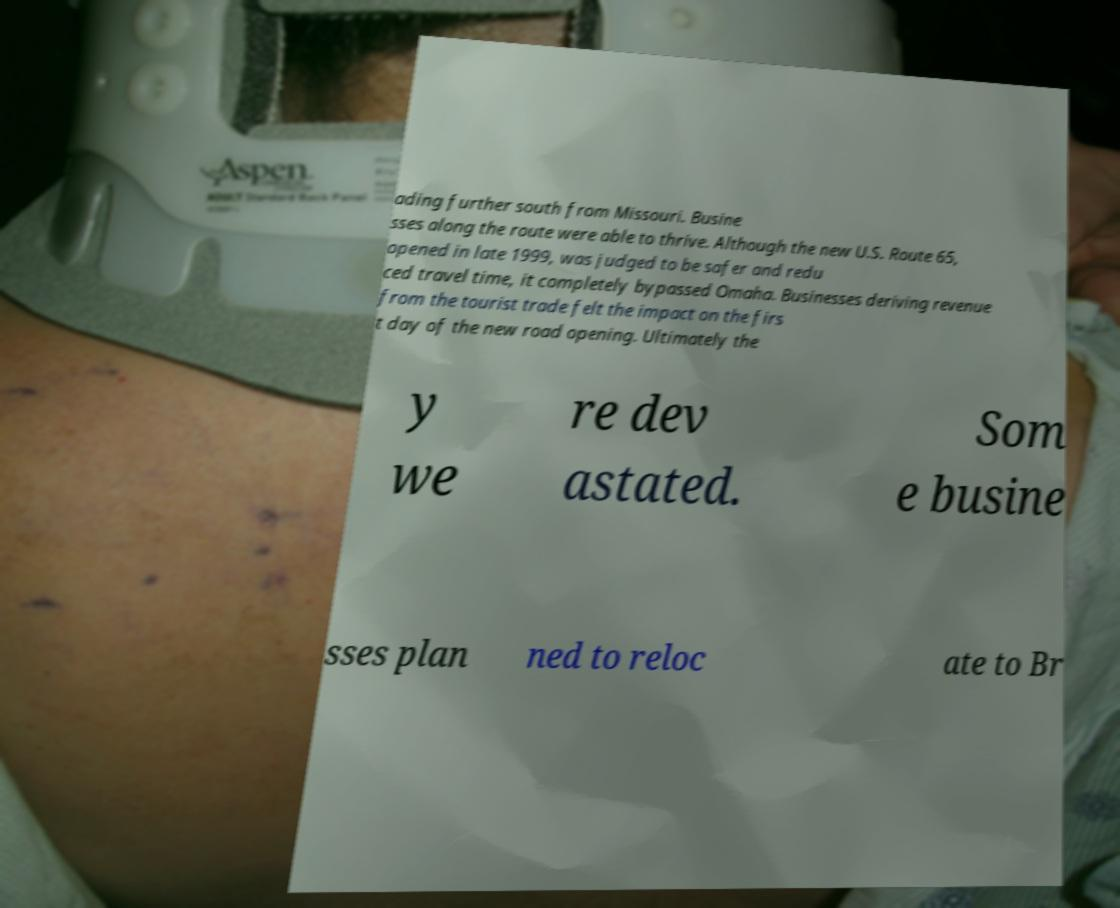For documentation purposes, I need the text within this image transcribed. Could you provide that? ading further south from Missouri. Busine sses along the route were able to thrive. Although the new U.S. Route 65, opened in late 1999, was judged to be safer and redu ced travel time, it completely bypassed Omaha. Businesses deriving revenue from the tourist trade felt the impact on the firs t day of the new road opening. Ultimately the y we re dev astated. Som e busine sses plan ned to reloc ate to Br 